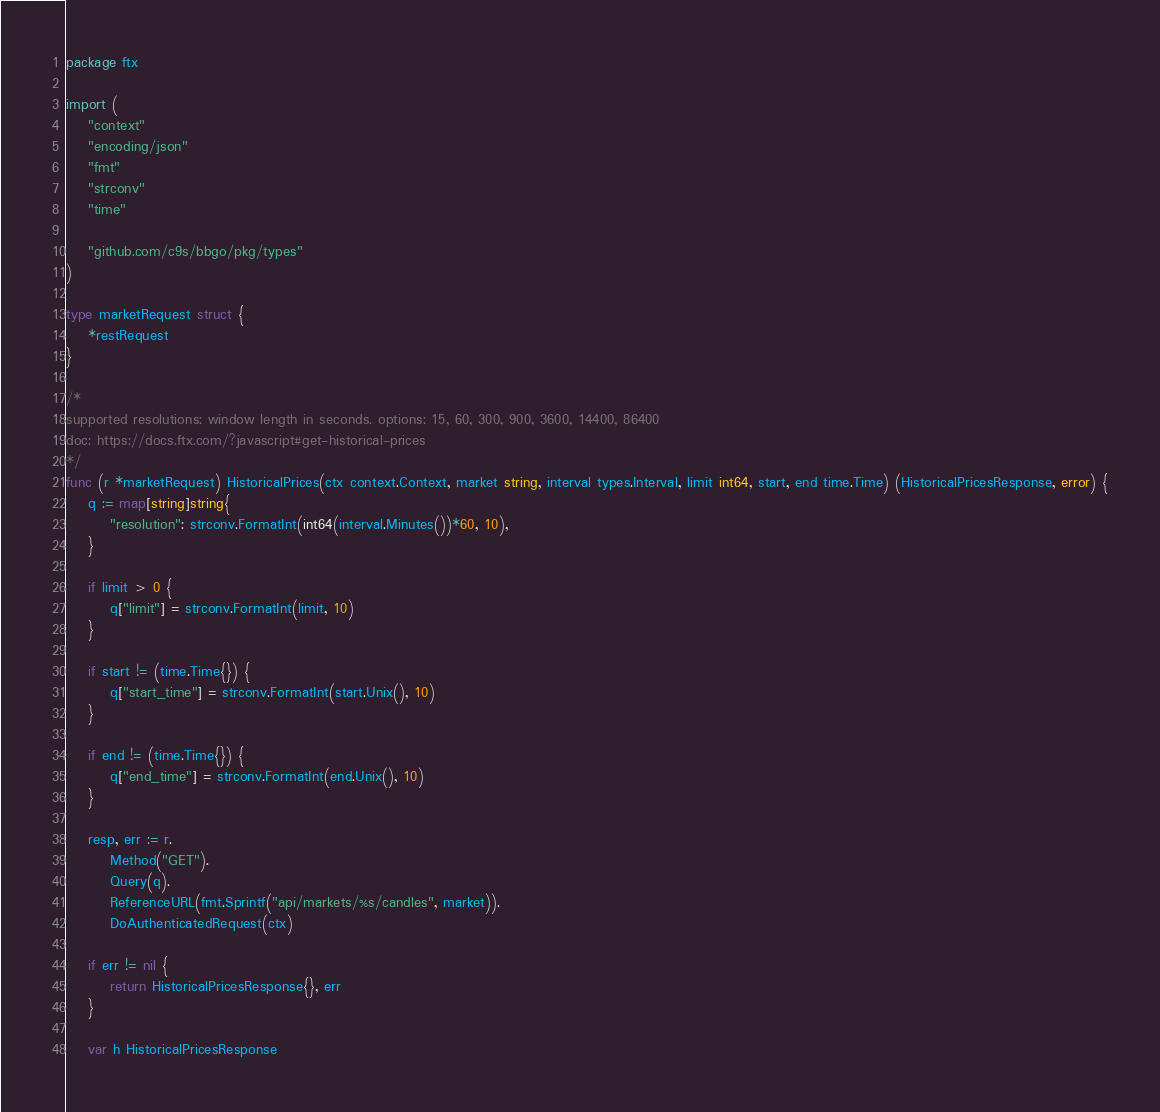Convert code to text. <code><loc_0><loc_0><loc_500><loc_500><_Go_>package ftx

import (
	"context"
	"encoding/json"
	"fmt"
	"strconv"
	"time"

	"github.com/c9s/bbgo/pkg/types"
)

type marketRequest struct {
	*restRequest
}

/*
supported resolutions: window length in seconds. options: 15, 60, 300, 900, 3600, 14400, 86400
doc: https://docs.ftx.com/?javascript#get-historical-prices
*/
func (r *marketRequest) HistoricalPrices(ctx context.Context, market string, interval types.Interval, limit int64, start, end time.Time) (HistoricalPricesResponse, error) {
	q := map[string]string{
		"resolution": strconv.FormatInt(int64(interval.Minutes())*60, 10),
	}

	if limit > 0 {
		q["limit"] = strconv.FormatInt(limit, 10)
	}

	if start != (time.Time{}) {
		q["start_time"] = strconv.FormatInt(start.Unix(), 10)
	}

	if end != (time.Time{}) {
		q["end_time"] = strconv.FormatInt(end.Unix(), 10)
	}

	resp, err := r.
		Method("GET").
		Query(q).
		ReferenceURL(fmt.Sprintf("api/markets/%s/candles", market)).
		DoAuthenticatedRequest(ctx)

	if err != nil {
		return HistoricalPricesResponse{}, err
	}

	var h HistoricalPricesResponse</code> 